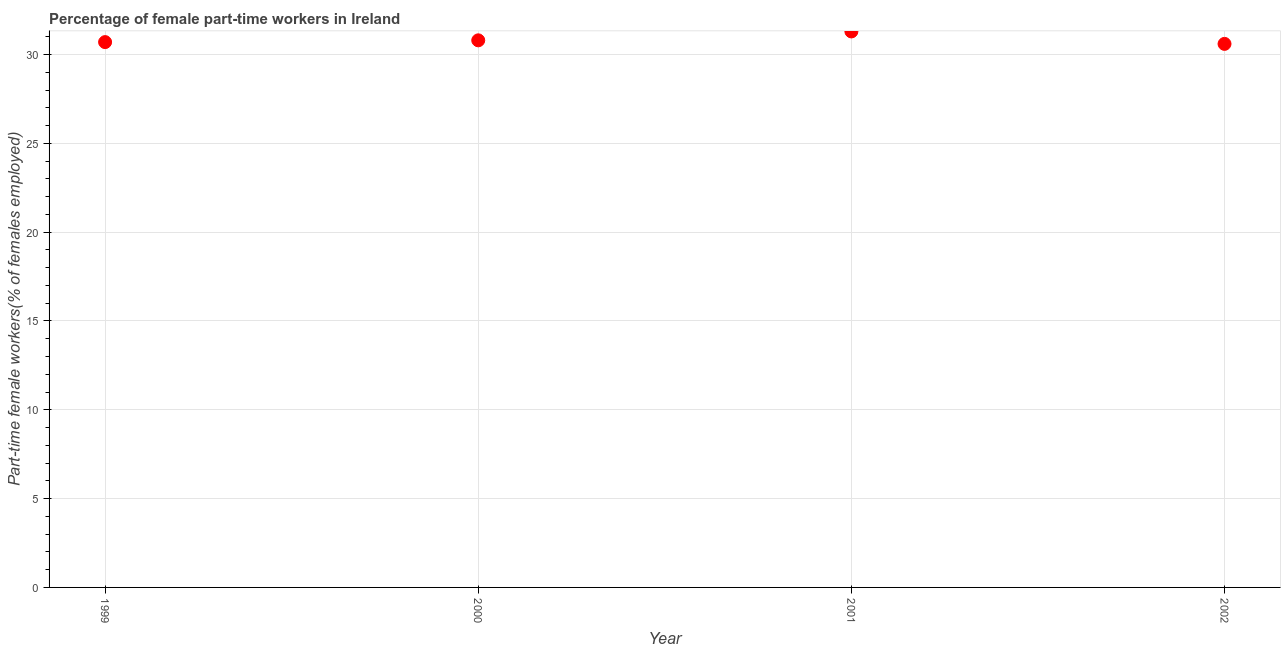What is the percentage of part-time female workers in 2001?
Make the answer very short. 31.3. Across all years, what is the maximum percentage of part-time female workers?
Ensure brevity in your answer.  31.3. Across all years, what is the minimum percentage of part-time female workers?
Your response must be concise. 30.6. In which year was the percentage of part-time female workers minimum?
Your answer should be very brief. 2002. What is the sum of the percentage of part-time female workers?
Your answer should be compact. 123.4. What is the average percentage of part-time female workers per year?
Offer a terse response. 30.85. What is the median percentage of part-time female workers?
Provide a succinct answer. 30.75. What is the ratio of the percentage of part-time female workers in 2001 to that in 2002?
Your answer should be very brief. 1.02. Is the percentage of part-time female workers in 1999 less than that in 2002?
Keep it short and to the point. No. Is the sum of the percentage of part-time female workers in 2001 and 2002 greater than the maximum percentage of part-time female workers across all years?
Provide a succinct answer. Yes. What is the difference between the highest and the lowest percentage of part-time female workers?
Ensure brevity in your answer.  0.7. How many years are there in the graph?
Keep it short and to the point. 4. What is the difference between two consecutive major ticks on the Y-axis?
Your answer should be compact. 5. Are the values on the major ticks of Y-axis written in scientific E-notation?
Provide a short and direct response. No. Does the graph contain any zero values?
Your answer should be compact. No. Does the graph contain grids?
Your answer should be compact. Yes. What is the title of the graph?
Offer a terse response. Percentage of female part-time workers in Ireland. What is the label or title of the X-axis?
Offer a terse response. Year. What is the label or title of the Y-axis?
Offer a terse response. Part-time female workers(% of females employed). What is the Part-time female workers(% of females employed) in 1999?
Ensure brevity in your answer.  30.7. What is the Part-time female workers(% of females employed) in 2000?
Keep it short and to the point. 30.8. What is the Part-time female workers(% of females employed) in 2001?
Provide a succinct answer. 31.3. What is the Part-time female workers(% of females employed) in 2002?
Give a very brief answer. 30.6. What is the difference between the Part-time female workers(% of females employed) in 1999 and 2001?
Your answer should be compact. -0.6. What is the difference between the Part-time female workers(% of females employed) in 2000 and 2002?
Offer a very short reply. 0.2. What is the ratio of the Part-time female workers(% of females employed) in 1999 to that in 2000?
Your answer should be compact. 1. What is the ratio of the Part-time female workers(% of females employed) in 2000 to that in 2002?
Ensure brevity in your answer.  1.01. 